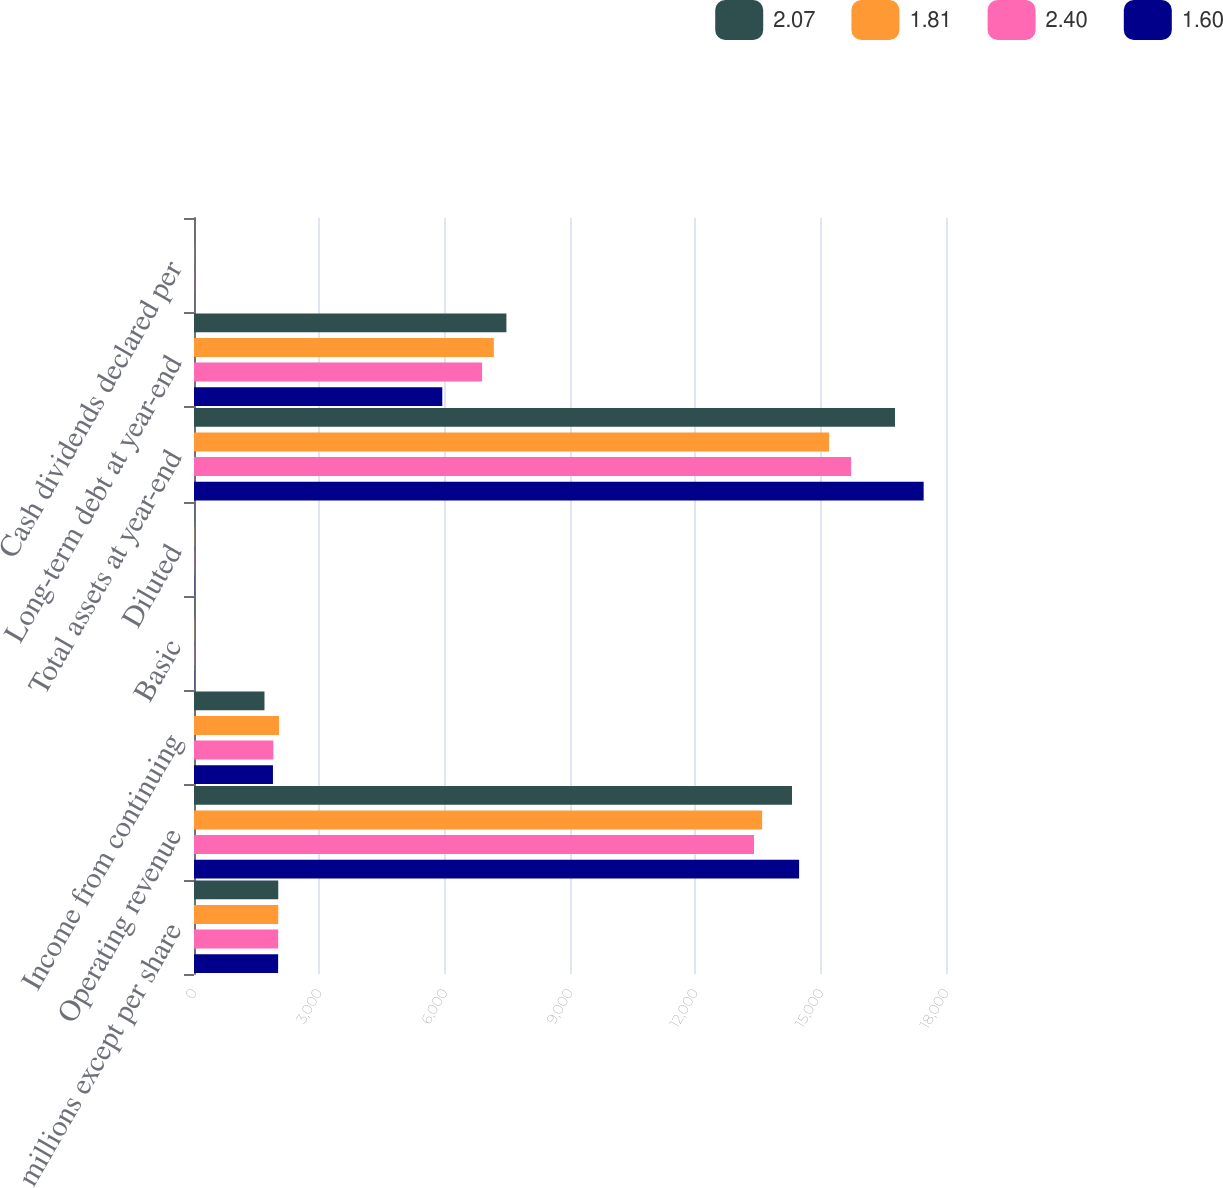<chart> <loc_0><loc_0><loc_500><loc_500><stacked_bar_chart><ecel><fcel>In millions except per share<fcel>Operating revenue<fcel>Income from continuing<fcel>Basic<fcel>Diluted<fcel>Total assets at year-end<fcel>Long-term debt at year-end<fcel>Cash dividends declared per<nl><fcel>2.07<fcel>2017<fcel>14314<fcel>1687<fcel>4.9<fcel>4.86<fcel>16780<fcel>7478<fcel>2.86<nl><fcel>1.81<fcel>2016<fcel>13599<fcel>2035<fcel>5.73<fcel>5.7<fcel>15201<fcel>7177<fcel>2.4<nl><fcel>2.4<fcel>2015<fcel>13405<fcel>1899<fcel>5.16<fcel>5.13<fcel>15729<fcel>6896<fcel>2.07<nl><fcel>1.6<fcel>2014<fcel>14484<fcel>1890<fcel>4.7<fcel>4.67<fcel>17465<fcel>5943<fcel>1.81<nl></chart> 